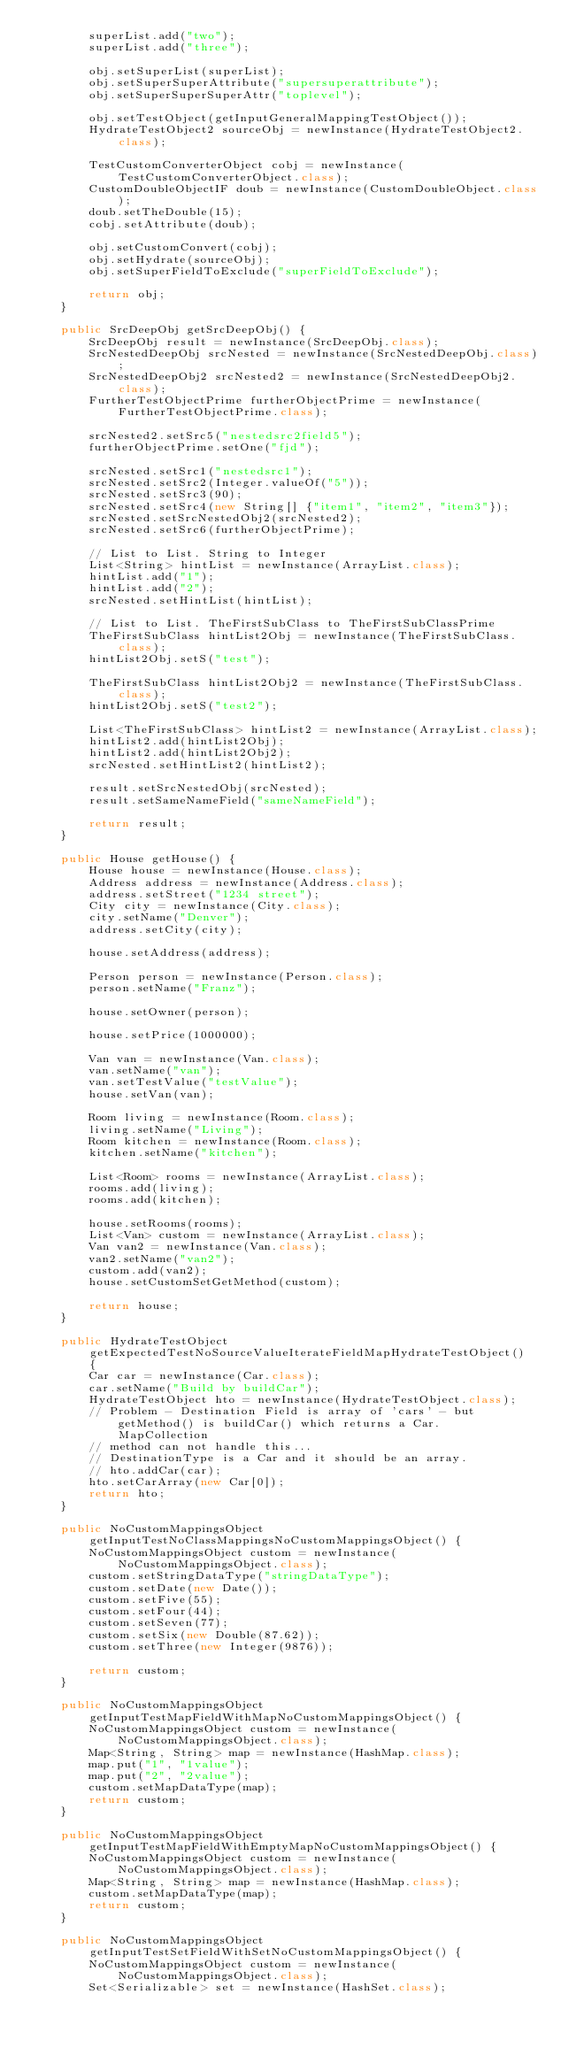<code> <loc_0><loc_0><loc_500><loc_500><_Java_>        superList.add("two");
        superList.add("three");

        obj.setSuperList(superList);
        obj.setSuperSuperAttribute("supersuperattribute");
        obj.setSuperSuperSuperAttr("toplevel");

        obj.setTestObject(getInputGeneralMappingTestObject());
        HydrateTestObject2 sourceObj = newInstance(HydrateTestObject2.class);

        TestCustomConverterObject cobj = newInstance(TestCustomConverterObject.class);
        CustomDoubleObjectIF doub = newInstance(CustomDoubleObject.class);
        doub.setTheDouble(15);
        cobj.setAttribute(doub);

        obj.setCustomConvert(cobj);
        obj.setHydrate(sourceObj);
        obj.setSuperFieldToExclude("superFieldToExclude");

        return obj;
    }

    public SrcDeepObj getSrcDeepObj() {
        SrcDeepObj result = newInstance(SrcDeepObj.class);
        SrcNestedDeepObj srcNested = newInstance(SrcNestedDeepObj.class);
        SrcNestedDeepObj2 srcNested2 = newInstance(SrcNestedDeepObj2.class);
        FurtherTestObjectPrime furtherObjectPrime = newInstance(FurtherTestObjectPrime.class);

        srcNested2.setSrc5("nestedsrc2field5");
        furtherObjectPrime.setOne("fjd");

        srcNested.setSrc1("nestedsrc1");
        srcNested.setSrc2(Integer.valueOf("5"));
        srcNested.setSrc3(90);
        srcNested.setSrc4(new String[] {"item1", "item2", "item3"});
        srcNested.setSrcNestedObj2(srcNested2);
        srcNested.setSrc6(furtherObjectPrime);

        // List to List. String to Integer
        List<String> hintList = newInstance(ArrayList.class);
        hintList.add("1");
        hintList.add("2");
        srcNested.setHintList(hintList);

        // List to List. TheFirstSubClass to TheFirstSubClassPrime
        TheFirstSubClass hintList2Obj = newInstance(TheFirstSubClass.class);
        hintList2Obj.setS("test");

        TheFirstSubClass hintList2Obj2 = newInstance(TheFirstSubClass.class);
        hintList2Obj.setS("test2");

        List<TheFirstSubClass> hintList2 = newInstance(ArrayList.class);
        hintList2.add(hintList2Obj);
        hintList2.add(hintList2Obj2);
        srcNested.setHintList2(hintList2);

        result.setSrcNestedObj(srcNested);
        result.setSameNameField("sameNameField");

        return result;
    }

    public House getHouse() {
        House house = newInstance(House.class);
        Address address = newInstance(Address.class);
        address.setStreet("1234 street");
        City city = newInstance(City.class);
        city.setName("Denver");
        address.setCity(city);

        house.setAddress(address);

        Person person = newInstance(Person.class);
        person.setName("Franz");

        house.setOwner(person);

        house.setPrice(1000000);

        Van van = newInstance(Van.class);
        van.setName("van");
        van.setTestValue("testValue");
        house.setVan(van);

        Room living = newInstance(Room.class);
        living.setName("Living");
        Room kitchen = newInstance(Room.class);
        kitchen.setName("kitchen");

        List<Room> rooms = newInstance(ArrayList.class);
        rooms.add(living);
        rooms.add(kitchen);

        house.setRooms(rooms);
        List<Van> custom = newInstance(ArrayList.class);
        Van van2 = newInstance(Van.class);
        van2.setName("van2");
        custom.add(van2);
        house.setCustomSetGetMethod(custom);

        return house;
    }

    public HydrateTestObject getExpectedTestNoSourceValueIterateFieldMapHydrateTestObject() {
        Car car = newInstance(Car.class);
        car.setName("Build by buildCar");
        HydrateTestObject hto = newInstance(HydrateTestObject.class);
        // Problem - Destination Field is array of 'cars' - but getMethod() is buildCar() which returns a Car. MapCollection
        // method can not handle this...
        // DestinationType is a Car and it should be an array.
        // hto.addCar(car);
        hto.setCarArray(new Car[0]);
        return hto;
    }

    public NoCustomMappingsObject getInputTestNoClassMappingsNoCustomMappingsObject() {
        NoCustomMappingsObject custom = newInstance(NoCustomMappingsObject.class);
        custom.setStringDataType("stringDataType");
        custom.setDate(new Date());
        custom.setFive(55);
        custom.setFour(44);
        custom.setSeven(77);
        custom.setSix(new Double(87.62));
        custom.setThree(new Integer(9876));

        return custom;
    }

    public NoCustomMappingsObject getInputTestMapFieldWithMapNoCustomMappingsObject() {
        NoCustomMappingsObject custom = newInstance(NoCustomMappingsObject.class);
        Map<String, String> map = newInstance(HashMap.class);
        map.put("1", "1value");
        map.put("2", "2value");
        custom.setMapDataType(map);
        return custom;
    }

    public NoCustomMappingsObject getInputTestMapFieldWithEmptyMapNoCustomMappingsObject() {
        NoCustomMappingsObject custom = newInstance(NoCustomMappingsObject.class);
        Map<String, String> map = newInstance(HashMap.class);
        custom.setMapDataType(map);
        return custom;
    }

    public NoCustomMappingsObject getInputTestSetFieldWithSetNoCustomMappingsObject() {
        NoCustomMappingsObject custom = newInstance(NoCustomMappingsObject.class);
        Set<Serializable> set = newInstance(HashSet.class);</code> 